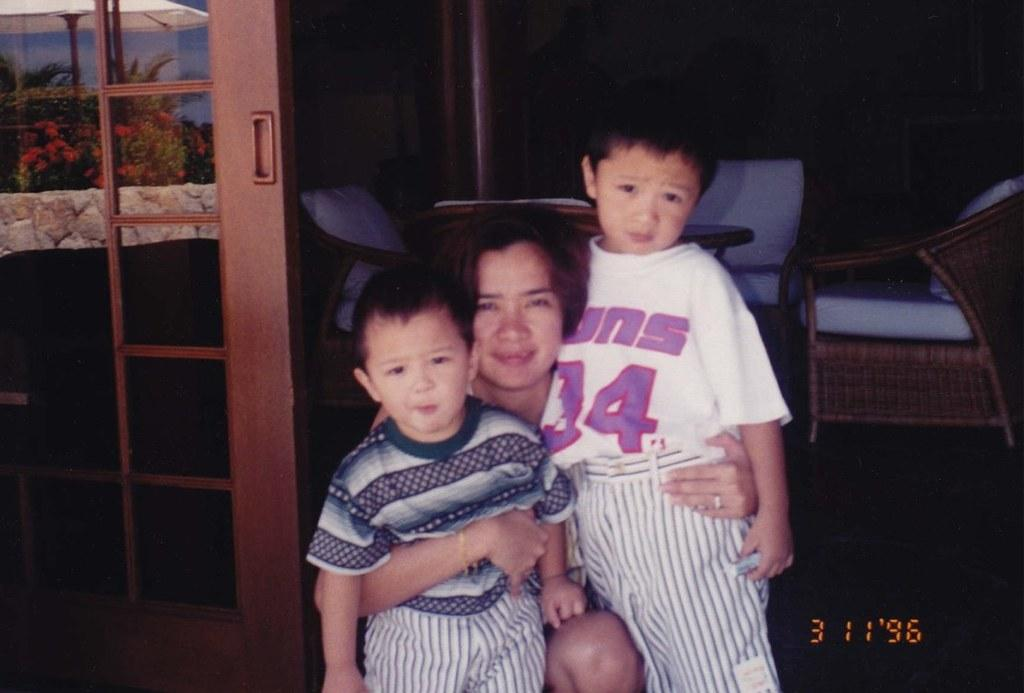Who is the main subject in the image? There is a woman in the image. Are there any other people in the image besides the woman? Yes, there are two children in the image. What objects are present in the image that people might sit on? There are chairs in the image. What architectural feature can be seen in the image? There is a door in the image. What type of natural environment is visible in the image? Trees are visible in the image. What type of flowers can be seen in the image? There are red color flowers in the image. What type of ear is visible in the image? There is no ear visible in the image. What type of family is depicted in the image? The image does not depict a specific family; it shows a woman and two children. What type of religious symbolism is present in the image? There is no religious symbolism present in the image. 